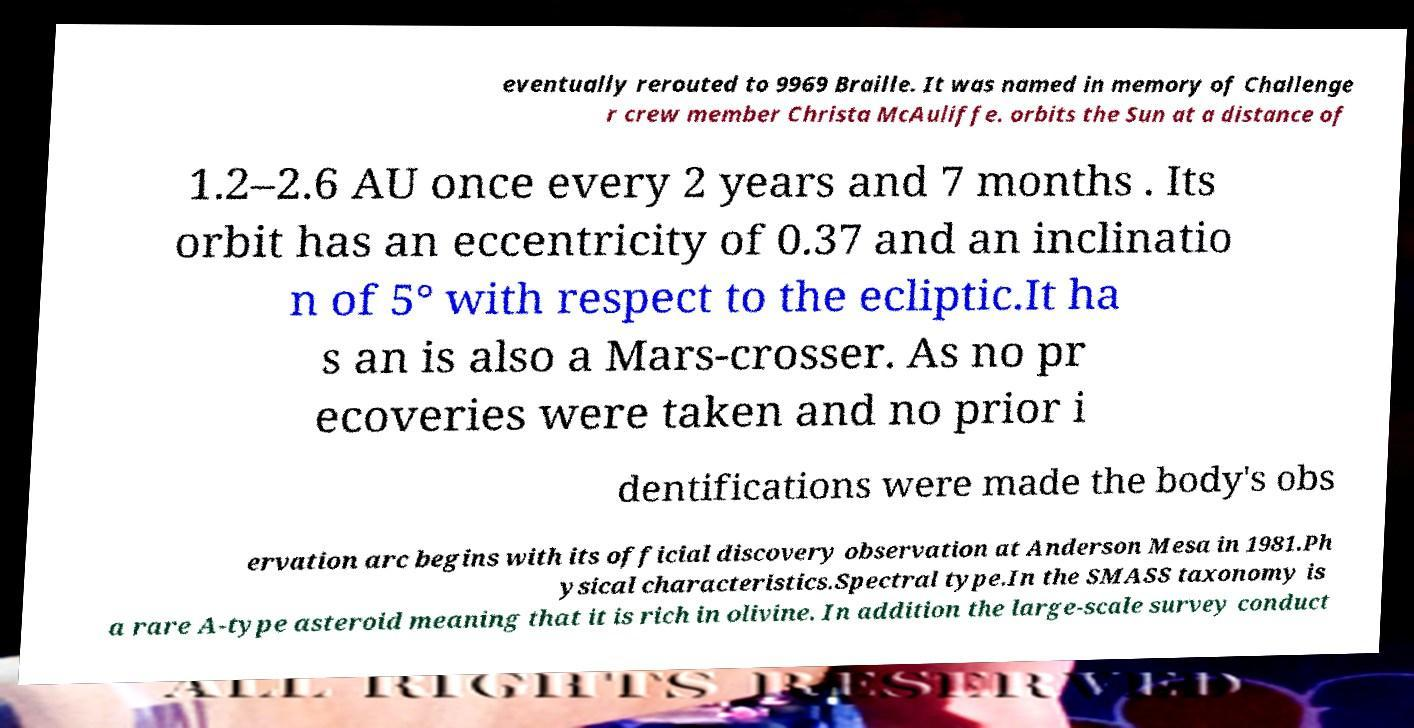Can you accurately transcribe the text from the provided image for me? eventually rerouted to 9969 Braille. It was named in memory of Challenge r crew member Christa McAuliffe. orbits the Sun at a distance of 1.2–2.6 AU once every 2 years and 7 months . Its orbit has an eccentricity of 0.37 and an inclinatio n of 5° with respect to the ecliptic.It ha s an is also a Mars-crosser. As no pr ecoveries were taken and no prior i dentifications were made the body's obs ervation arc begins with its official discovery observation at Anderson Mesa in 1981.Ph ysical characteristics.Spectral type.In the SMASS taxonomy is a rare A-type asteroid meaning that it is rich in olivine. In addition the large-scale survey conduct 